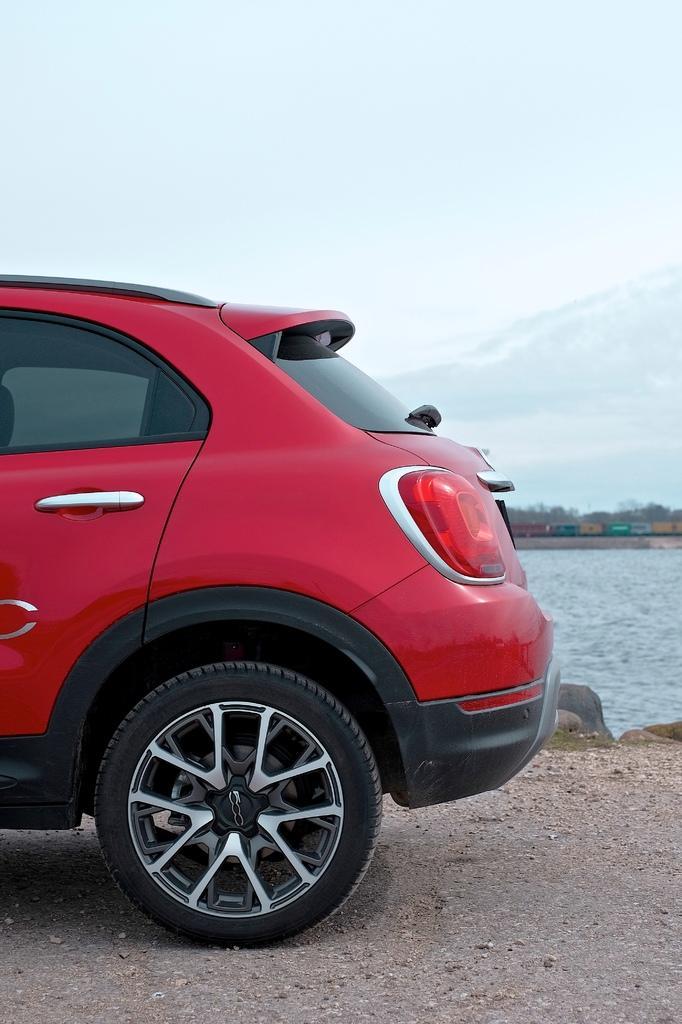How would you summarize this image in a sentence or two? In the center of the image we can see one car, which is in red color. In the background, we can see the sky, clouds, trees, one train, water, stones etc. 